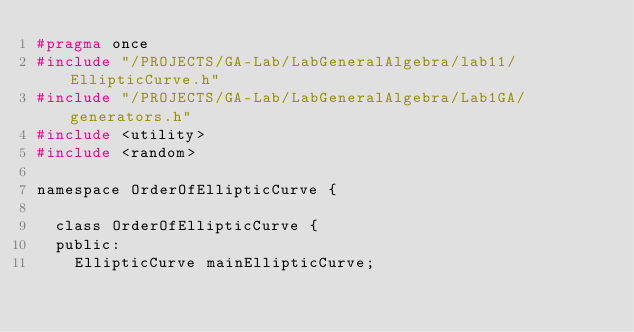<code> <loc_0><loc_0><loc_500><loc_500><_C_>#pragma once
#include "/PROJECTS/GA-Lab/LabGeneralAlgebra/lab11/EllipticCurve.h"
#include "/PROJECTS/GA-Lab/LabGeneralAlgebra/Lab1GA/generators.h"
#include <utility>
#include <random>

namespace OrderOfEllipticCurve {

	class OrderOfEllipticCurve {
	public:
		EllipticCurve mainEllipticCurve;</code> 